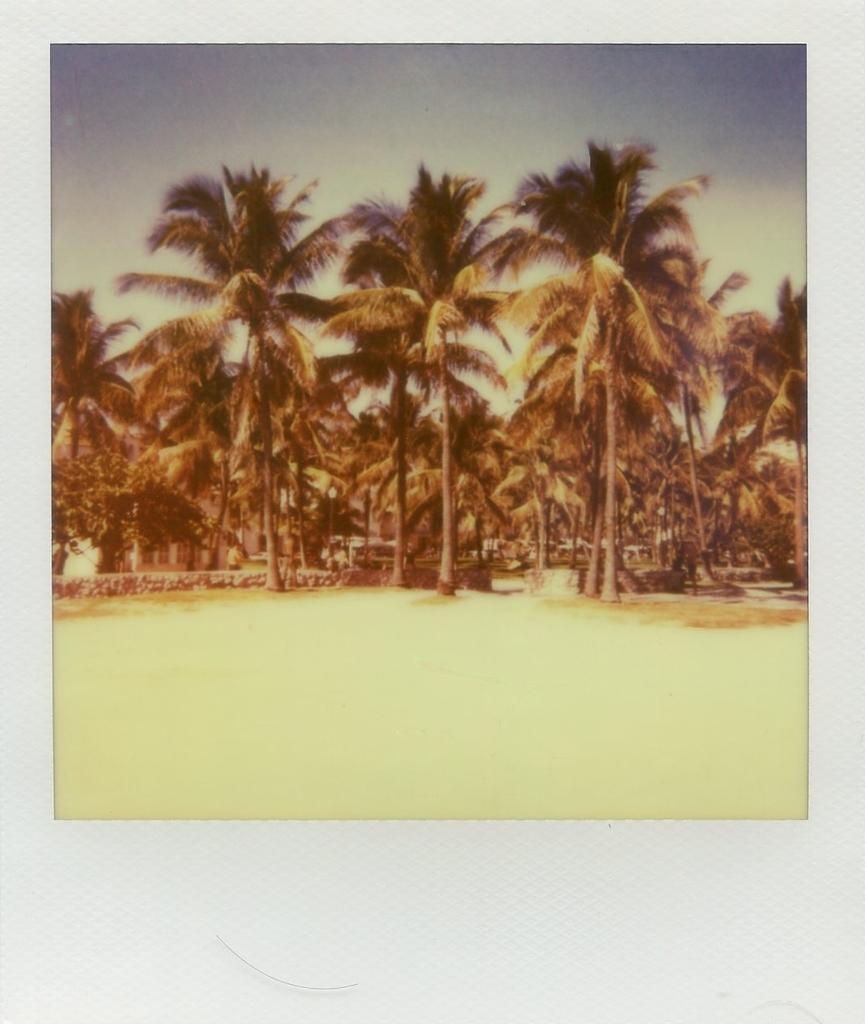How would you summarize this image in a sentence or two? In this image we can see trees, sky. At the bottom of the image there is ground. 